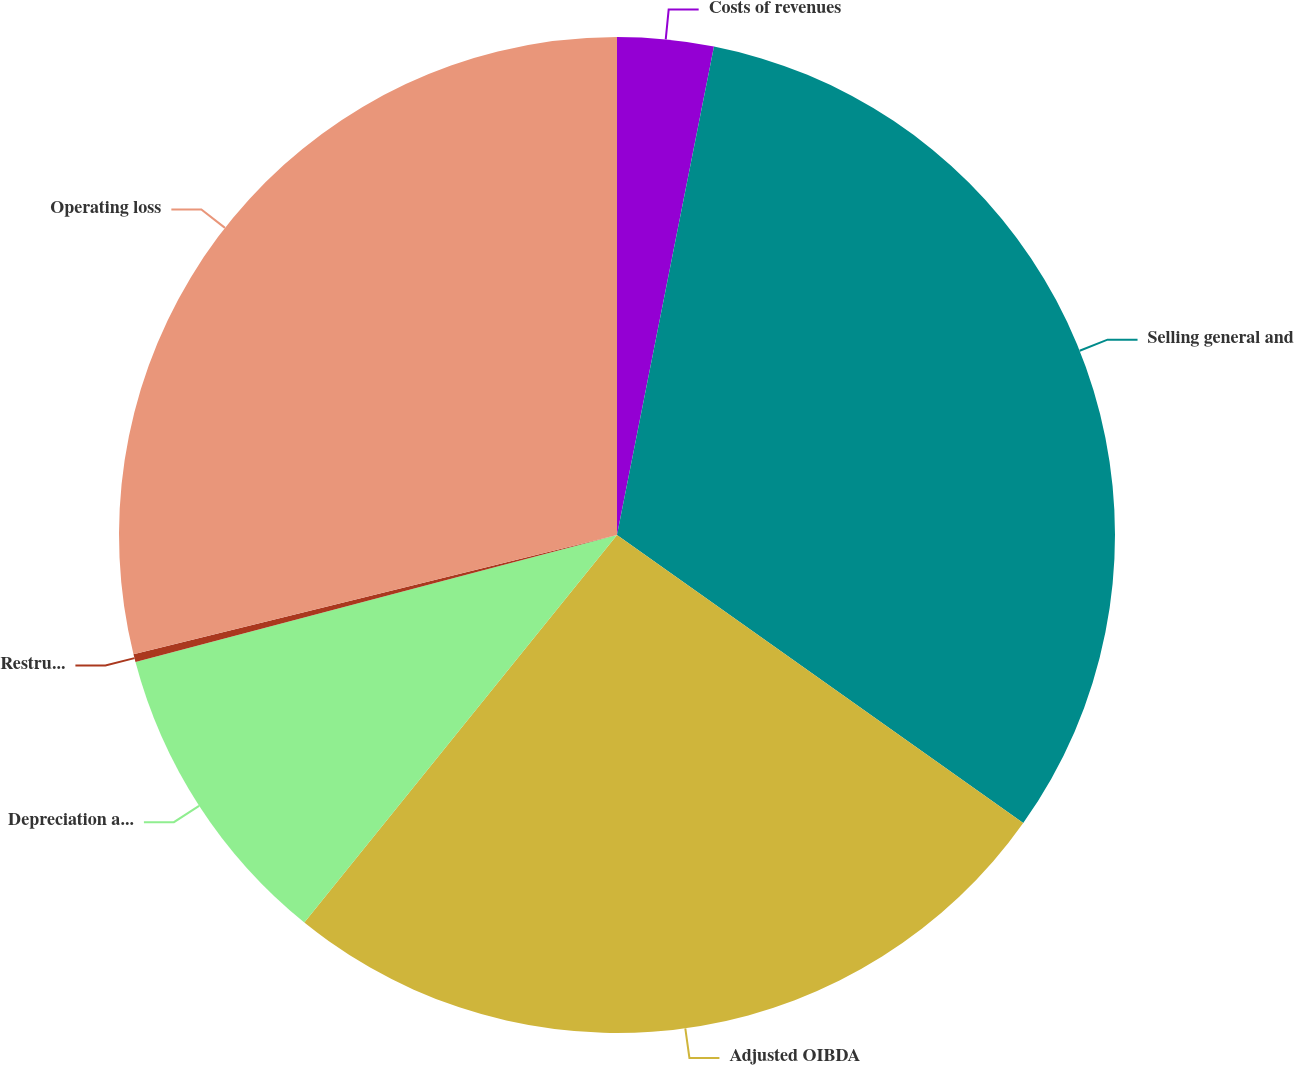<chart> <loc_0><loc_0><loc_500><loc_500><pie_chart><fcel>Costs of revenues<fcel>Selling general and<fcel>Adjusted OIBDA<fcel>Depreciation and amortization<fcel>Restructuring and impairment<fcel>Operating loss<nl><fcel>3.12%<fcel>31.7%<fcel>25.99%<fcel>10.09%<fcel>0.26%<fcel>28.85%<nl></chart> 